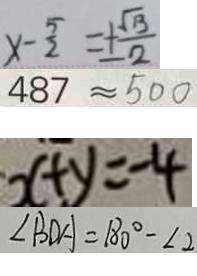Convert formula to latex. <formula><loc_0><loc_0><loc_500><loc_500>x - \frac { 5 } { 2 } = \pm \frac { \sqrt { 1 3 } } { 2 } 
 4 8 7 \approx 5 0 0 
 x + y = - 4 
 \angle B D A = 1 8 0 ^ { \circ } - \angle 2</formula> 